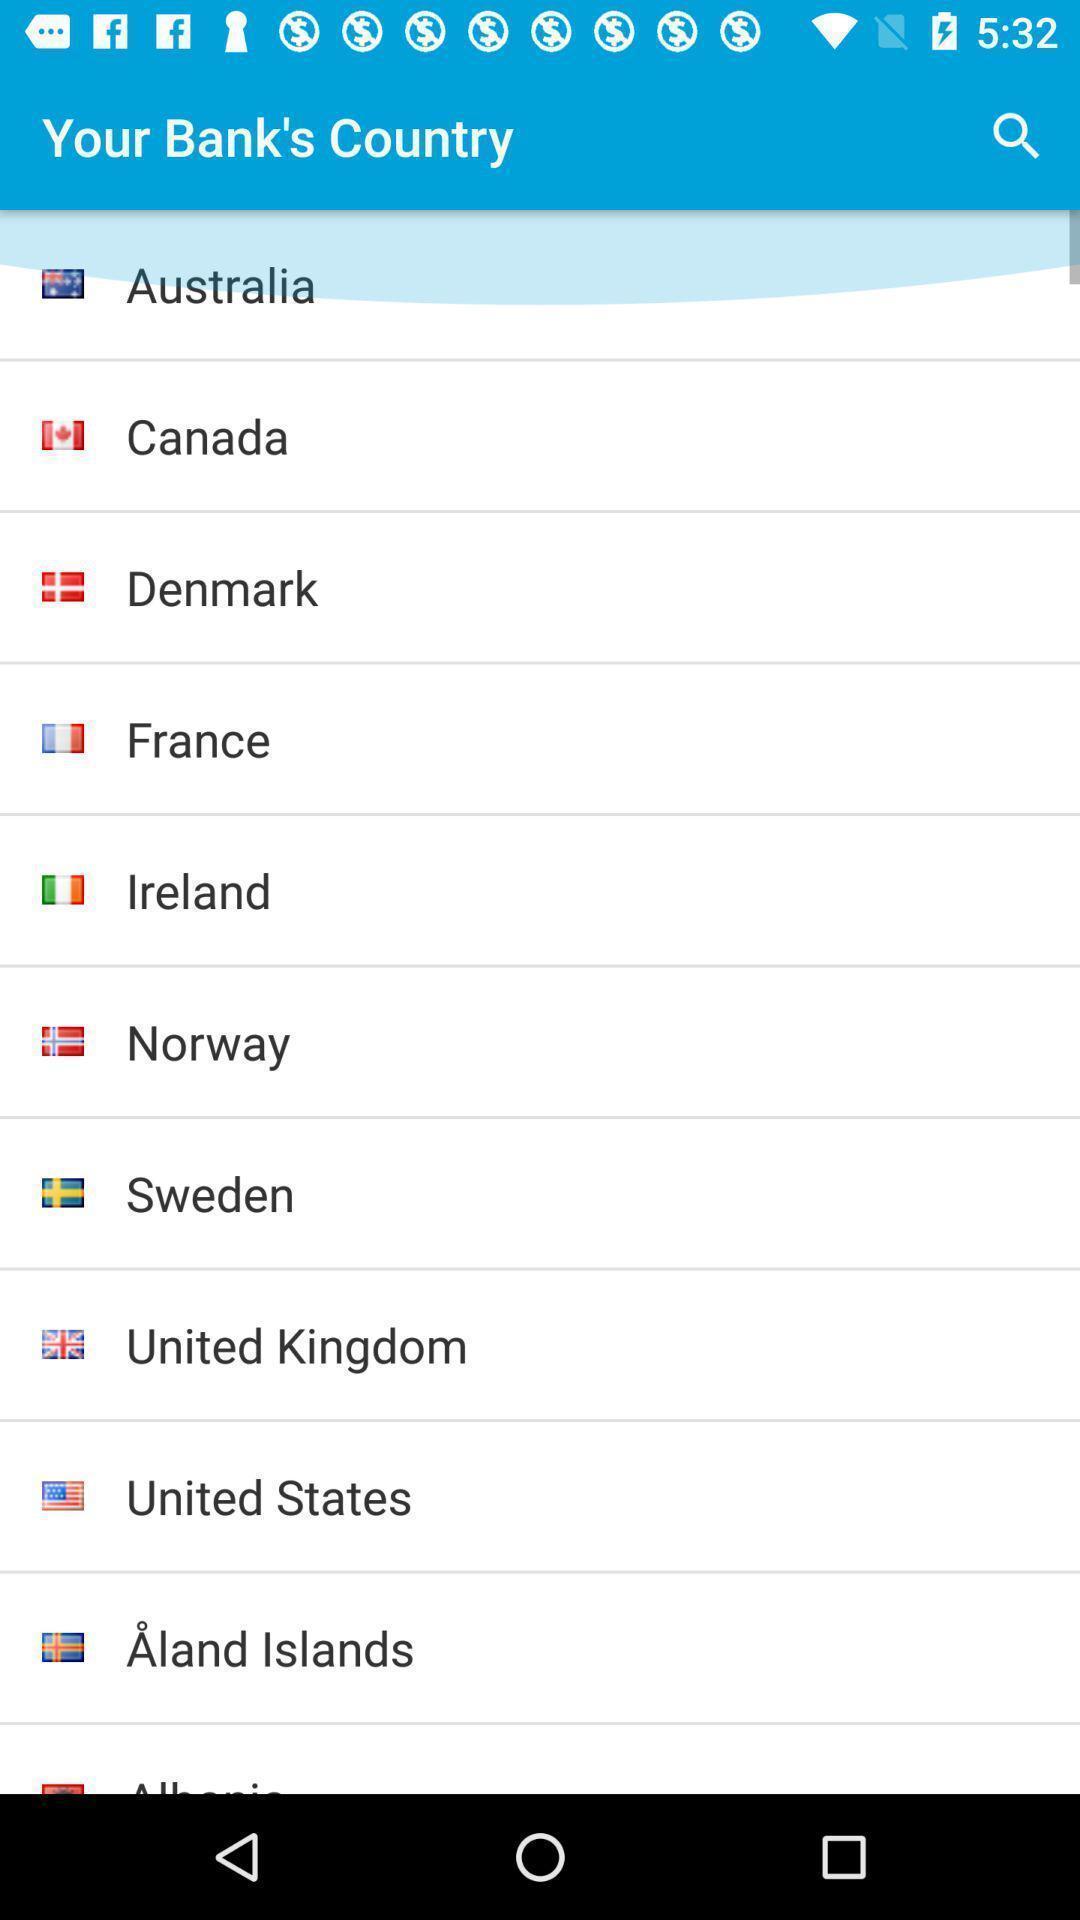Provide a description of this screenshot. Search page to find country. 